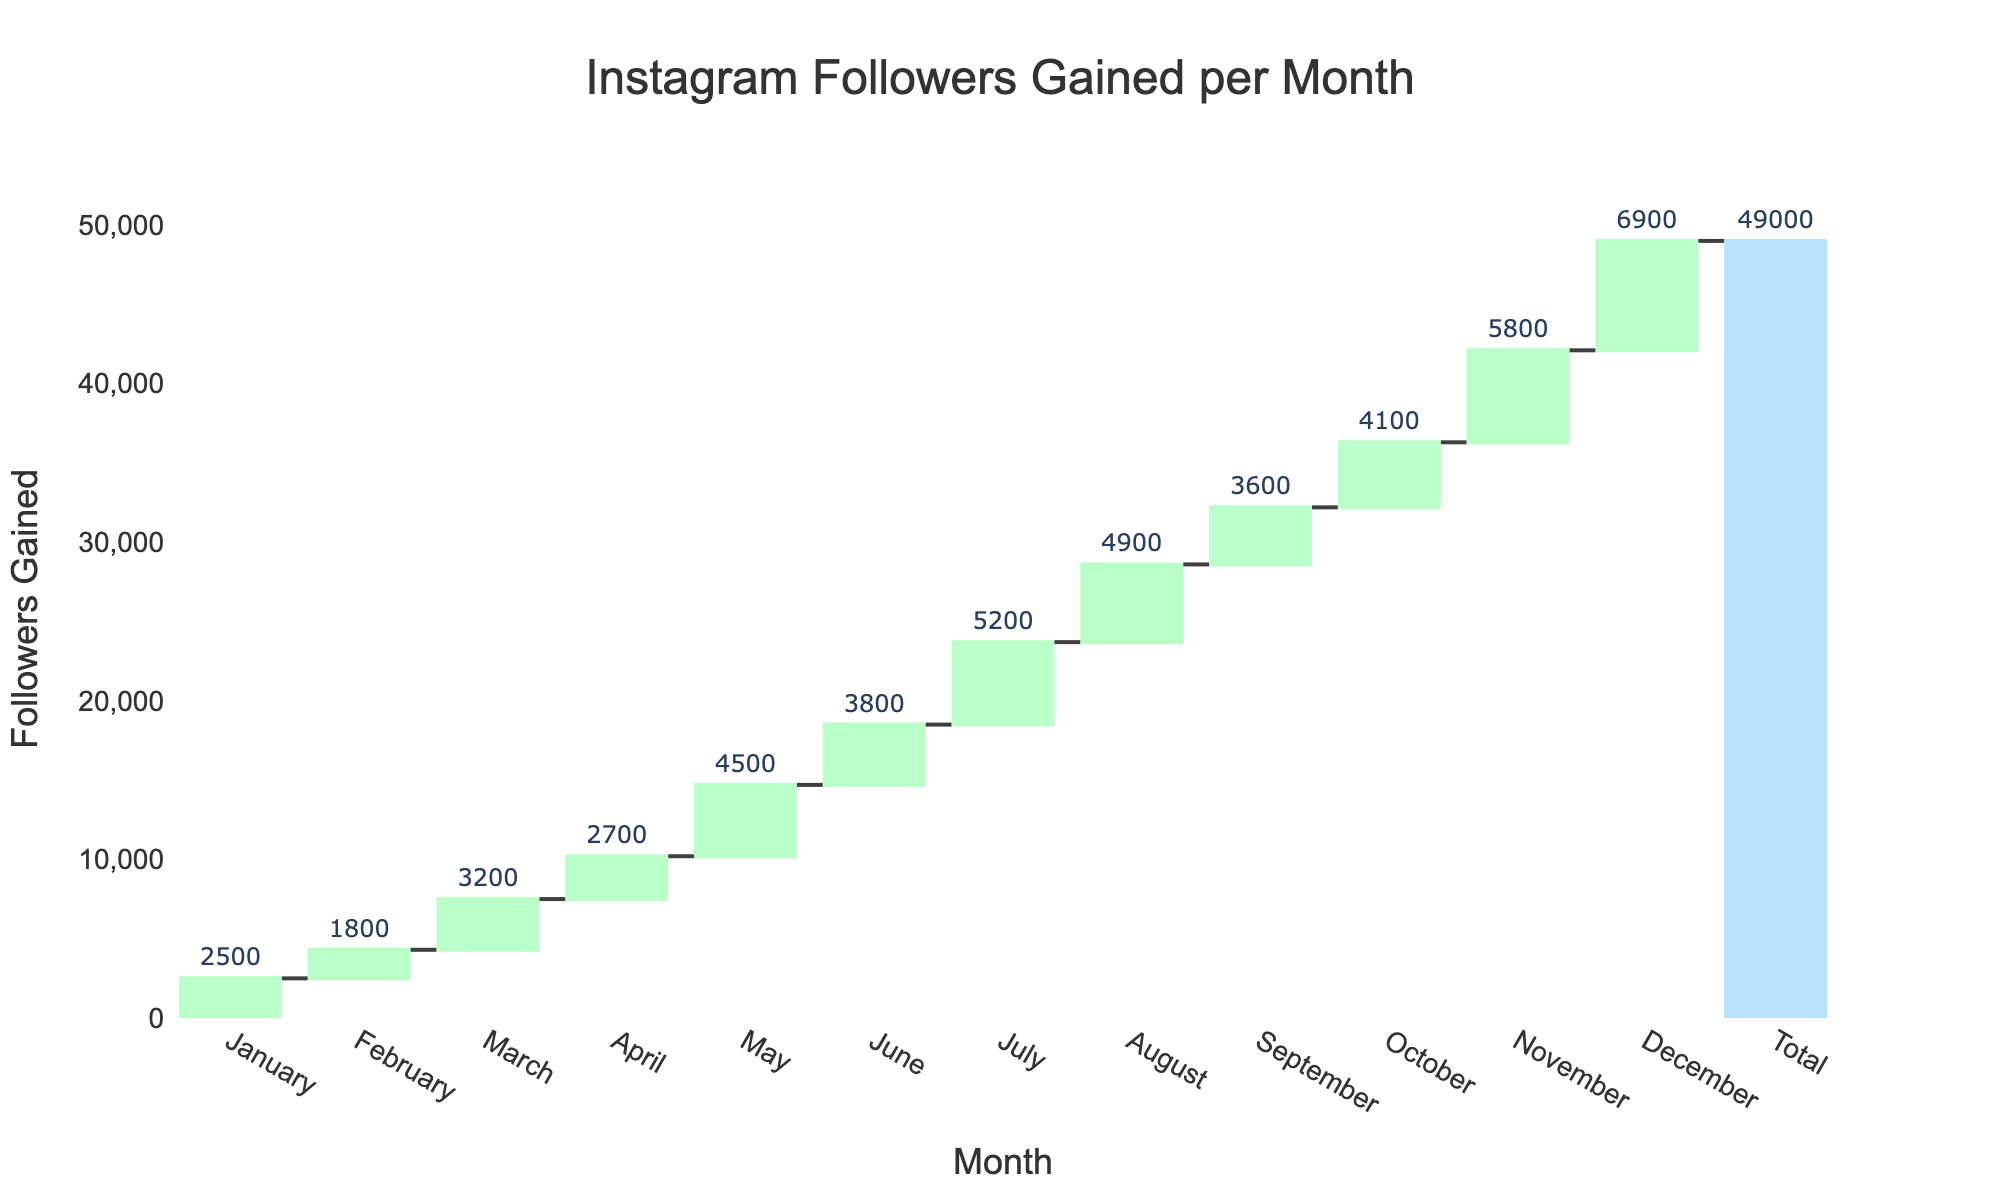What's the title of the chart? The title of the chart is usually found at the top and is clearly labeled. In this case, the chart's title is "Instagram Followers Gained per Month".
Answer: Instagram Followers Gained per Month What month had the highest increase in followers? By observing the height of the bars in the chart, December has the highest bar, indicating the highest increase in followers. December saw a gain of 6900 followers, which is the tallest bar in the chart.
Answer: December How many total followers were gained throughout the year? Look for the total value, which can be found next to the "Total" label in the chart. The total followers gained throughout the year is the sum of the gains from each month.
Answer: 48,200 Which month had the lowest increase in followers? By comparing the heights of the bars in the chart, February has the shortest bar, indicating the lowest increase in followers. February saw a gain of 1800 followers, which is the smallest bar in the chart.
Answer: February What is the cumulative number of followers gained by the end of June? The cumulative number can be found by adding the followers gained from January to June. In the chart, follow the cumulative line up to June. The cumulative number of followers by the end of June is 2500 (January) + 1800 (February) + 3200 (March) + 2700 (April) + 4500 (May) + 3800 (June) = 18,500.
Answer: 18,500 How does the follower gain in July compare to the gain in September? Look at the bars for July and September. July's gain is 5200 followers, whereas September's gain is 3600 followers. By subtracting September's gain from July's gain, we see that July gained 1600 more followers than September.
Answer: 1600 more in July Which quarter (3-month period) had the highest total gain in followers? Divide the year into quarters: Q1 (Jan-Mar), Q2 (Apr-Jun), Q3 (Jul-Sep), Q4 (Oct-Dec). Calculate the total gain for each quarter and compare them.
- Q1: 2500 + 1800 + 3200 = 7500
- Q2: 2700 + 4500 + 3800 = 11000
- Q3: 5200 + 4900 + 3600 = 13700
- Q4: 4100 + 5800 + 6900 = 16800
The highest total gain in followers is in Q4.
Answer: Q4 What are the main visual differences between months with increasing and decreasing markers? In the waterfall chart, increasing markers are typically shown in green, while decreasing markers would be in a different color. Here, all months had an increase, with no decreases visible. Therefore, all bars are green.
Answer: Increasing markers are green What is the average number of followers gained per month? Sum the total followers gained over the year (48,200) and divide by the number of months (12). The average number of followers gained per month is 48,200 ÷ 12 = 4016.67.
Answer: 4016.67 